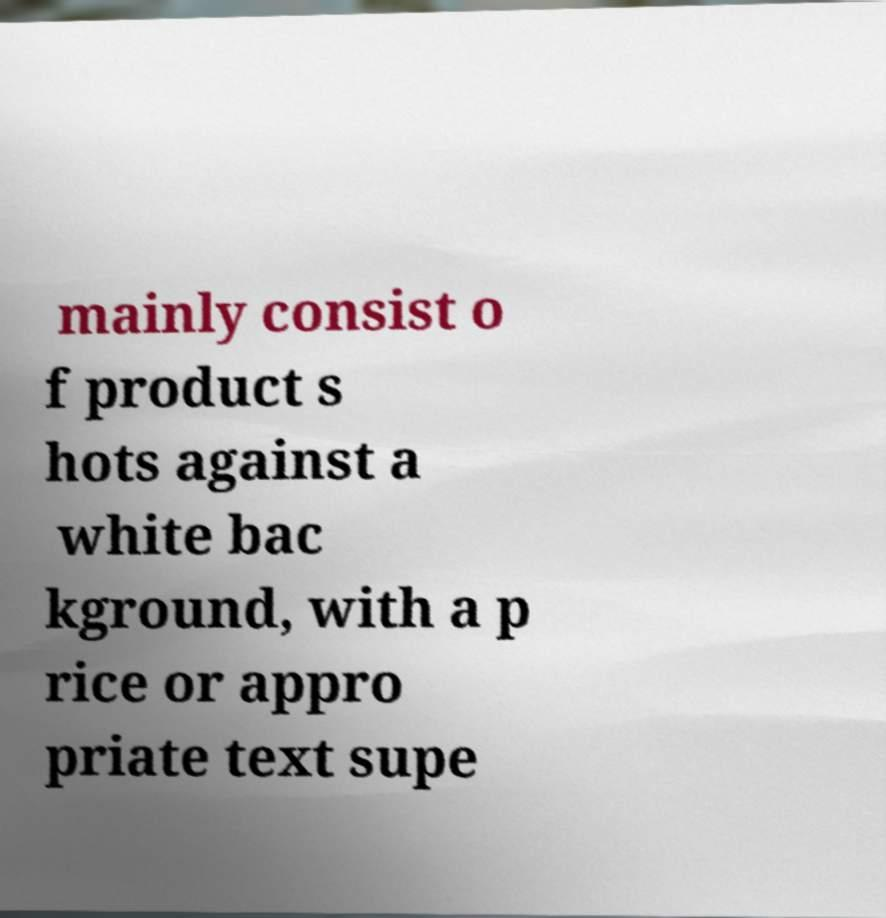Please read and relay the text visible in this image. What does it say? mainly consist o f product s hots against a white bac kground, with a p rice or appro priate text supe 